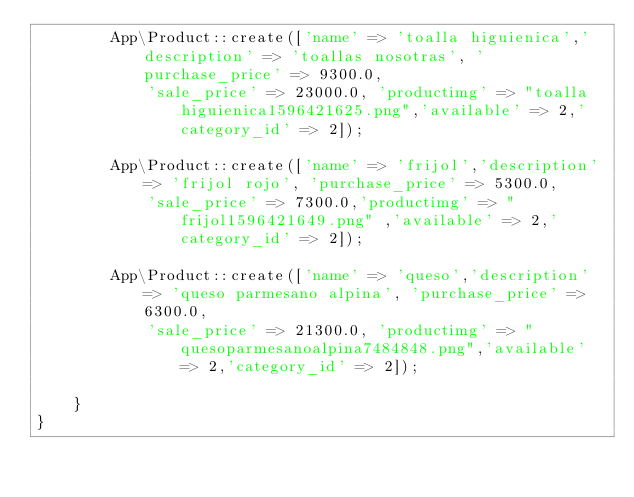Convert code to text. <code><loc_0><loc_0><loc_500><loc_500><_PHP_>        App\Product::create(['name' => 'toalla higuienica','description' => 'toallas nosotras', 'purchase_price' => 9300.0,
            'sale_price' => 23000.0, 'productimg' => "toalla higuienica1596421625.png",'available' => 2,'category_id' => 2]);

        App\Product::create(['name' => 'frijol','description' => 'frijol rojo', 'purchase_price' => 5300.0,
            'sale_price' => 7300.0,'productimg' => "frijol1596421649.png" ,'available' => 2,'category_id' => 2]);

        App\Product::create(['name' => 'queso','description' => 'queso parmesano alpina', 'purchase_price' => 6300.0,
            'sale_price' => 21300.0, 'productimg' => "quesoparmesanoalpina7484848.png",'available' => 2,'category_id' => 2]);

    }
}
</code> 